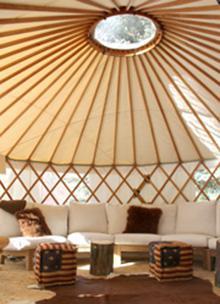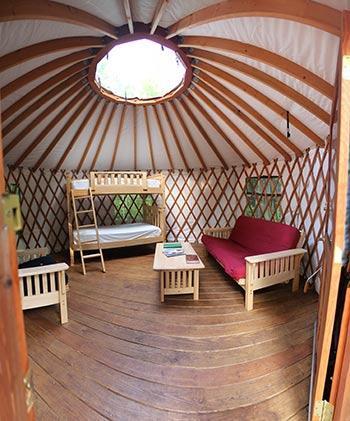The first image is the image on the left, the second image is the image on the right. For the images shown, is this caption "An image shows the exterior framework of an unfinished building with a cone-shaped roof." true? Answer yes or no. No. The first image is the image on the left, the second image is the image on the right. For the images shown, is this caption "One of the images is showing the hut from the outside." true? Answer yes or no. No. 